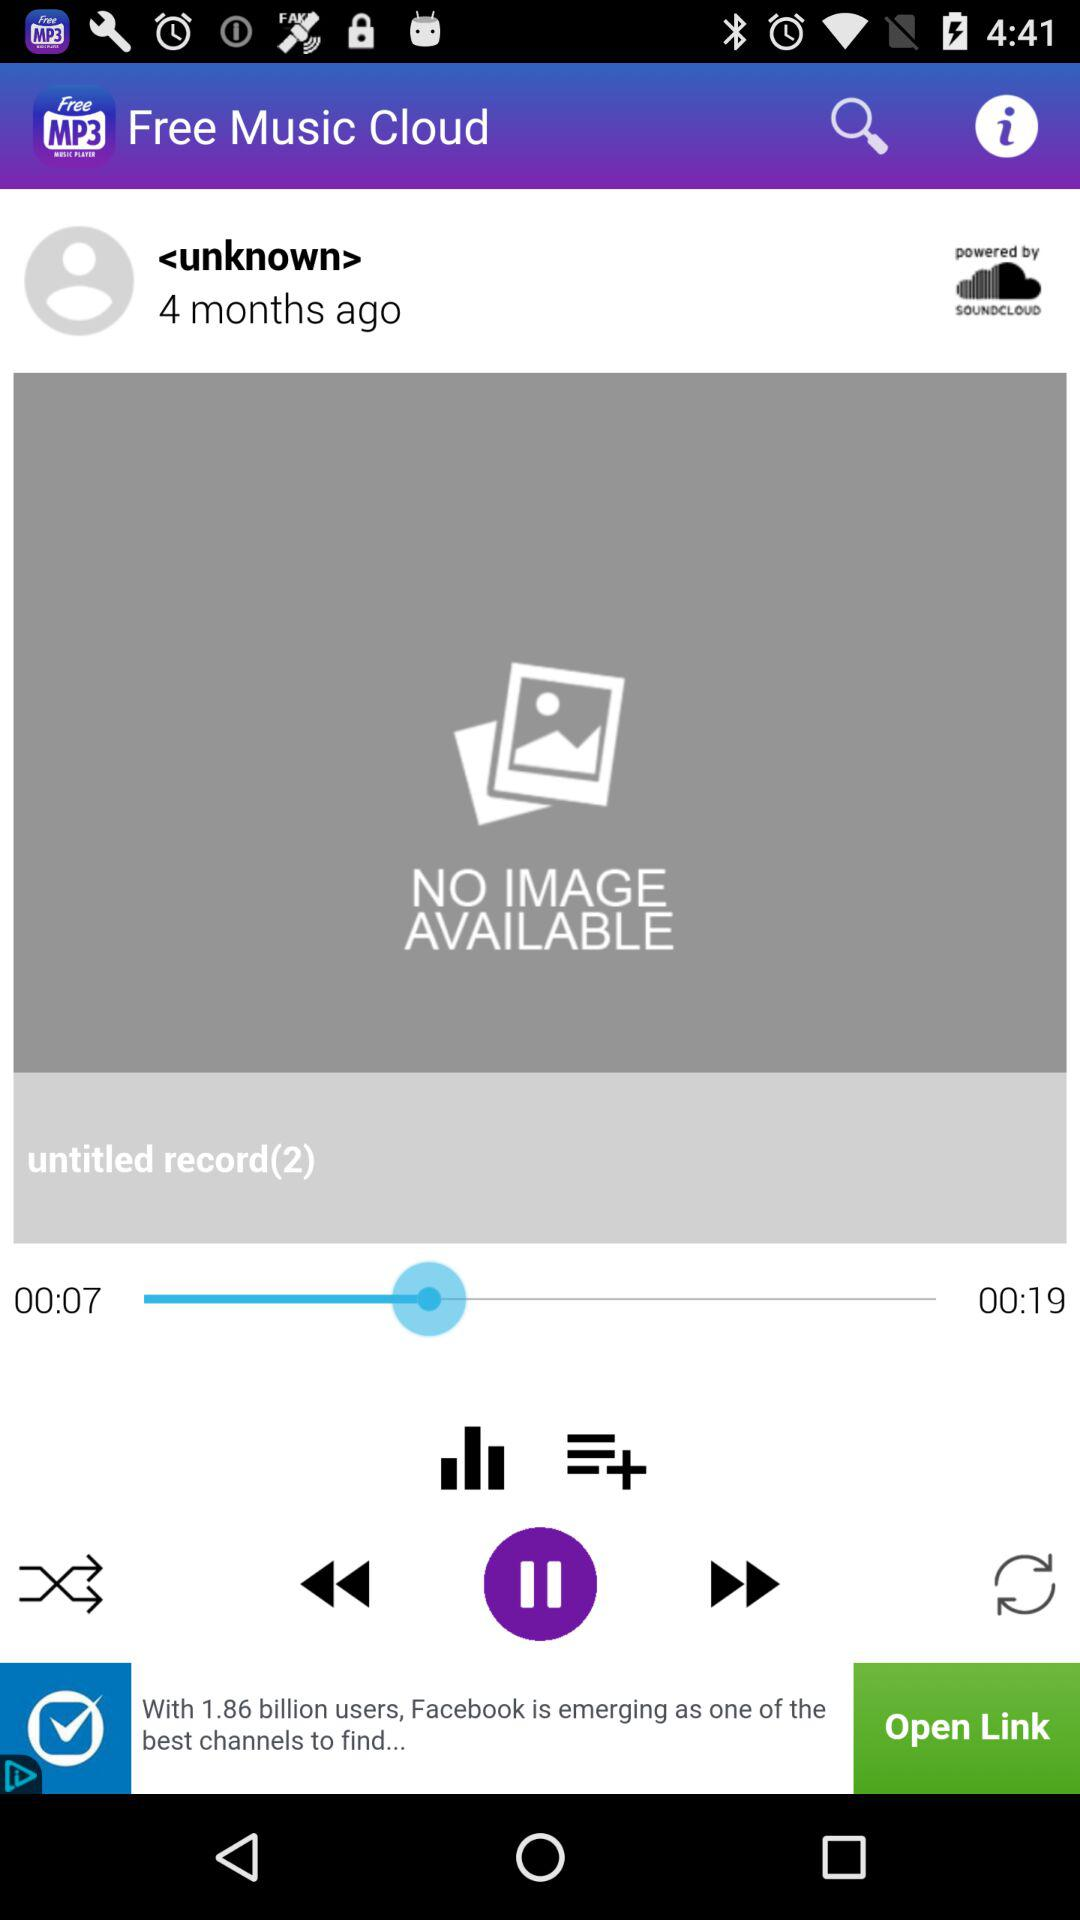What is the application name? The application name is "Free Music Cloud". 